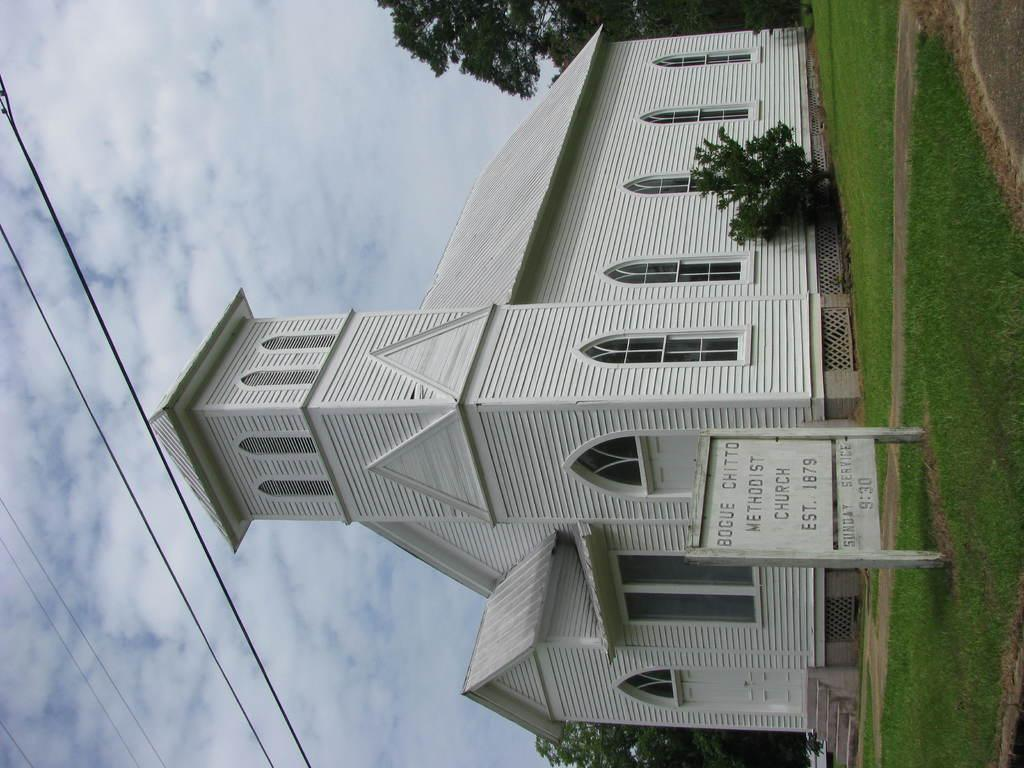<image>
Offer a succinct explanation of the picture presented. the little white methodist church was establised in 1879 